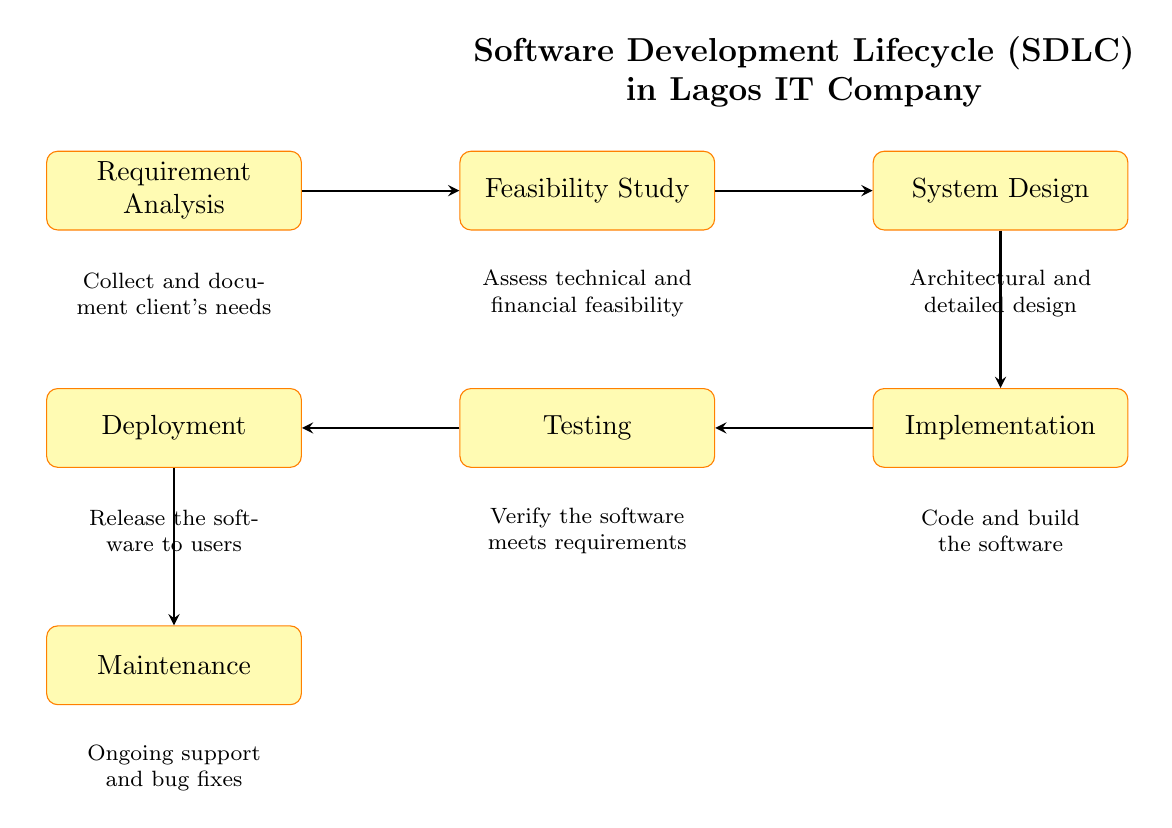What is the first step in the software development lifecycle? The diagram indicates that the first step is "Requirement Analysis," which is represented at the leftmost position in the flowchart.
Answer: Requirement Analysis How many main processes are depicted in the diagram? By counting the distinct nodes listed in the flowchart, we can identify six main processes: Requirement Analysis, Feasibility Study, System Design, Implementation, Testing, and Deployment.
Answer: Six What comes immediately after System Design? The flowchart shows that "Implementation" follows "System Design," as indicated by the arrow going to the right from the "System Design" node to the "Implementation" node.
Answer: Implementation What stage involves assessing technical and financial feasibility? The diagram clearly states that the "Feasibility Study" stage is where technical and financial feasibility is assessed, as described in the associated explanation under that node.
Answer: Feasibility Study What process is responsible for ongoing support and bug fixes? The diagram specifies "Maintenance" as the process that involves ongoing support and bug fixes, as it is the last node in the flowchart, located below "Deployment."
Answer: Maintenance Which stage verifies that the software meets requirements? According to the diagram, "Testing" is the stage dedicated to verifying that the software meets the specified requirements, indicated by the arrow pointing towards it from "Implementation."
Answer: Testing How many arrows are used in the flowchart? By examining the connections between the processes in the diagram, we can see there are five arrows representing the flow from one process to the next, connecting all six stages in order.
Answer: Five What is the main focus of the Requirement Analysis phase? The diagram outlines that "Requirement Analysis" focuses on collecting and documenting the client's needs, serving as a critical starting point for the workflow.
Answer: Collect and document client's needs What is the final step in the software development lifecycle? The flowchart indicates that the last step is "Maintenance," which follows "Deployment" and is necessary for the ongoing support of the software.
Answer: Maintenance 